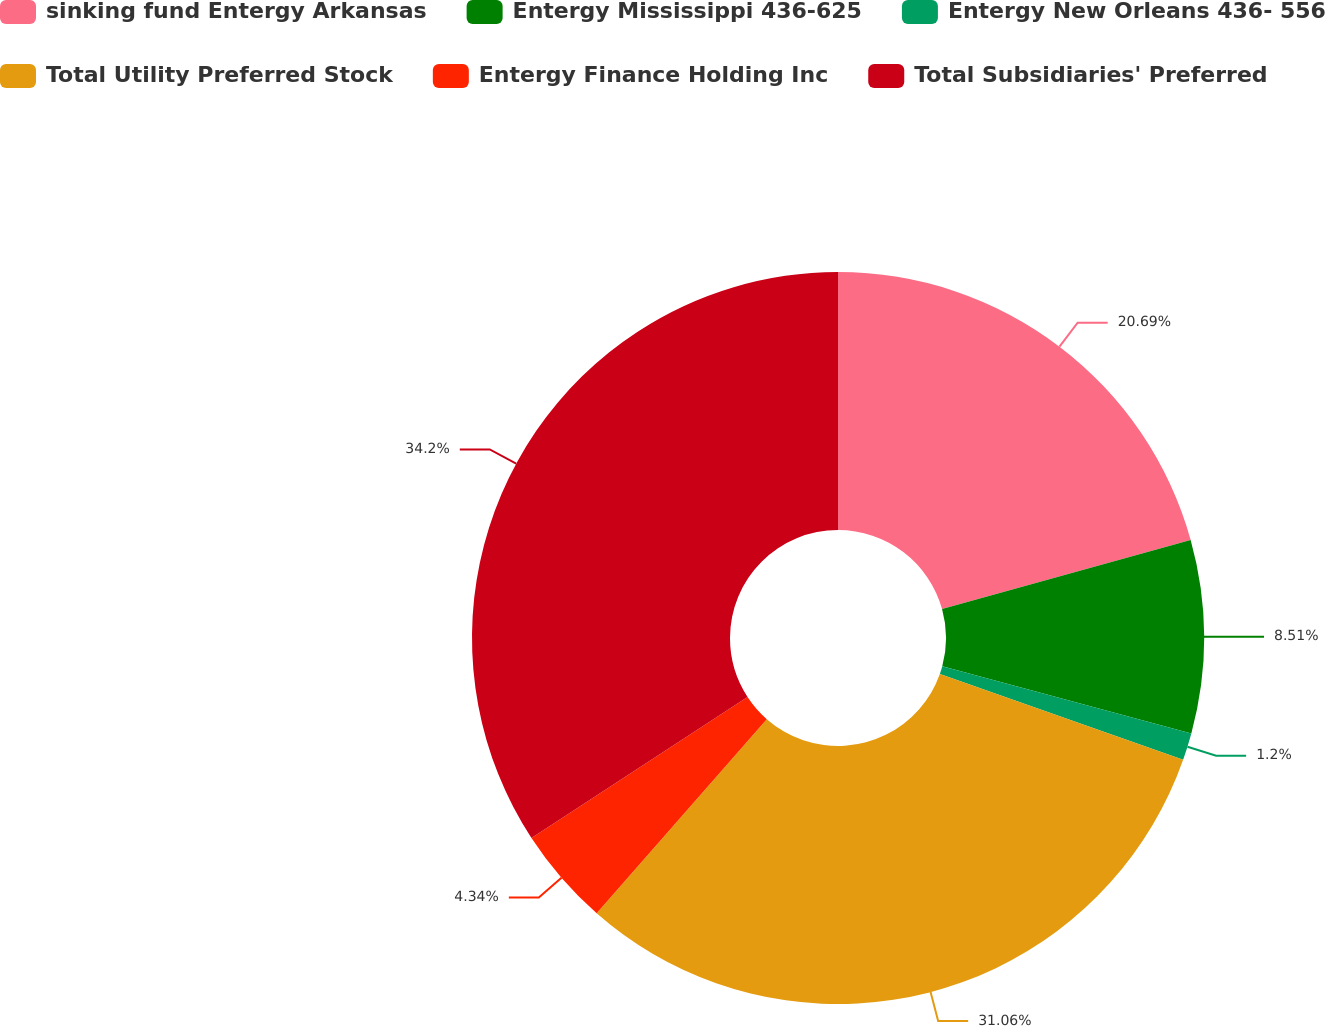<chart> <loc_0><loc_0><loc_500><loc_500><pie_chart><fcel>sinking fund Entergy Arkansas<fcel>Entergy Mississippi 436-625<fcel>Entergy New Orleans 436- 556<fcel>Total Utility Preferred Stock<fcel>Entergy Finance Holding Inc<fcel>Total Subsidiaries' Preferred<nl><fcel>20.69%<fcel>8.51%<fcel>1.2%<fcel>31.06%<fcel>4.34%<fcel>34.2%<nl></chart> 